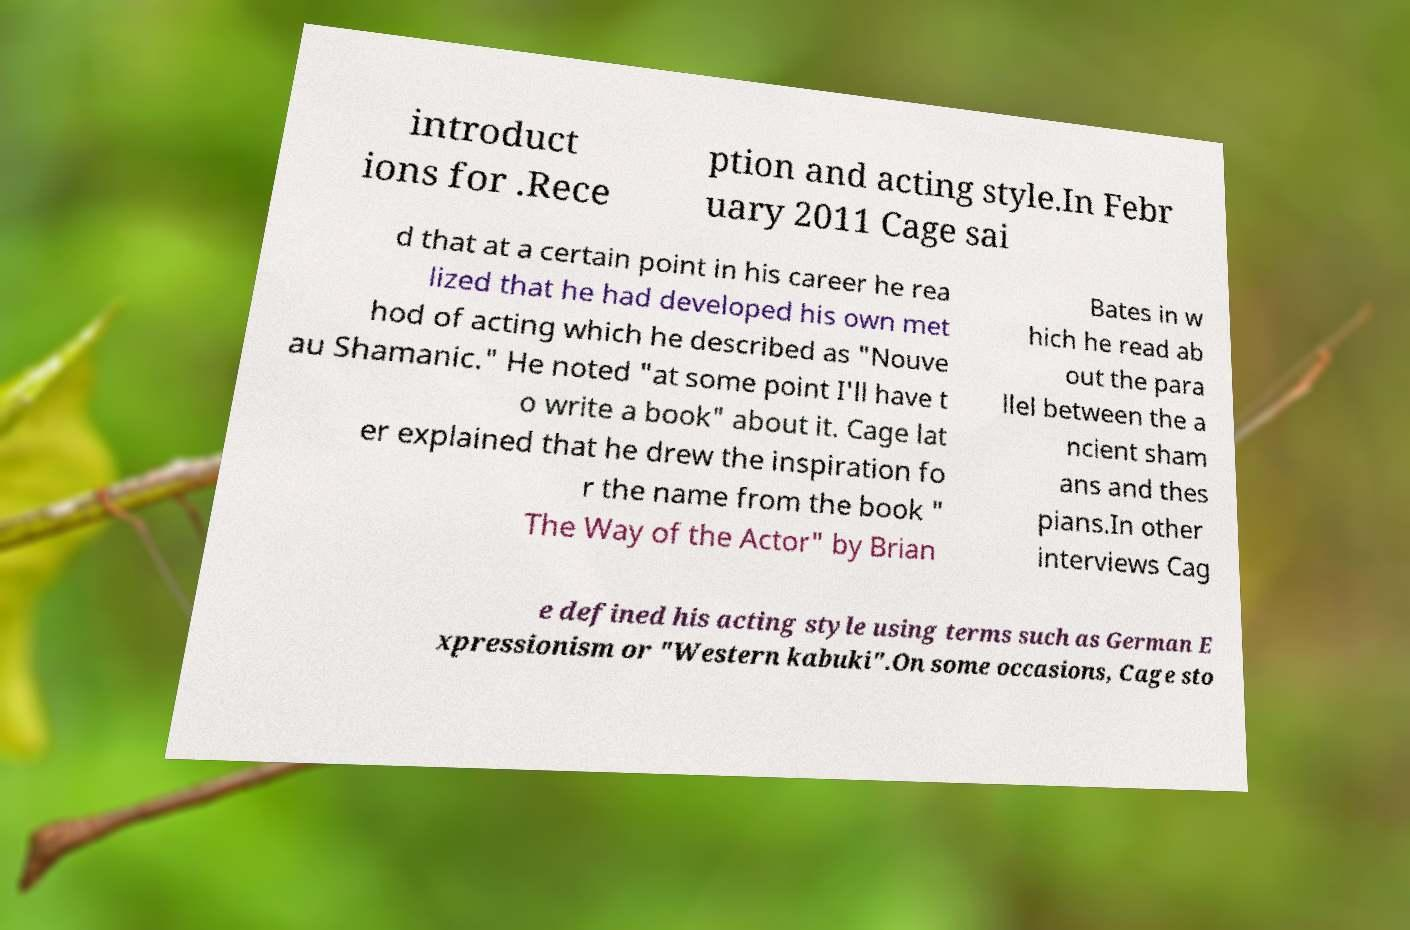What messages or text are displayed in this image? I need them in a readable, typed format. introduct ions for .Rece ption and acting style.In Febr uary 2011 Cage sai d that at a certain point in his career he rea lized that he had developed his own met hod of acting which he described as "Nouve au Shamanic." He noted "at some point I'll have t o write a book" about it. Cage lat er explained that he drew the inspiration fo r the name from the book " The Way of the Actor" by Brian Bates in w hich he read ab out the para llel between the a ncient sham ans and thes pians.In other interviews Cag e defined his acting style using terms such as German E xpressionism or "Western kabuki".On some occasions, Cage sto 